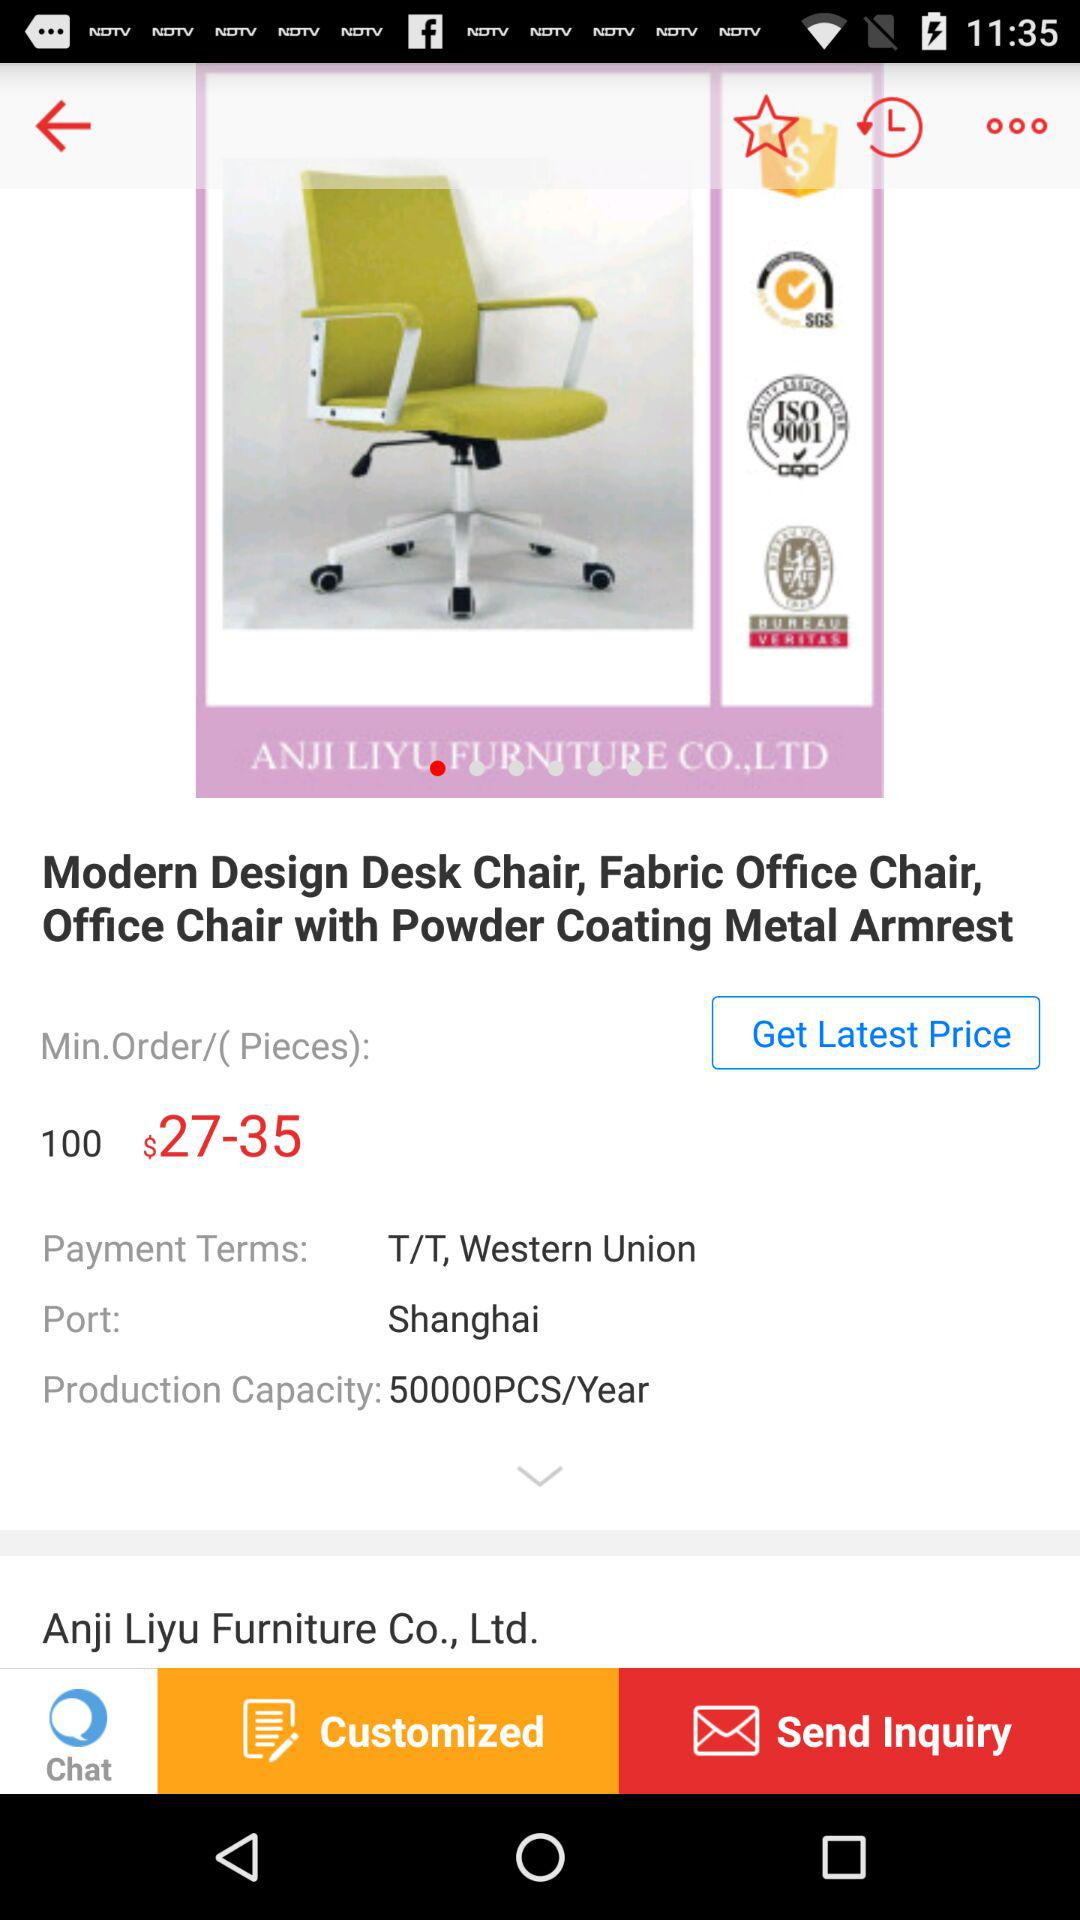How much is the minimum order?
Answer the question using a single word or phrase. 100 